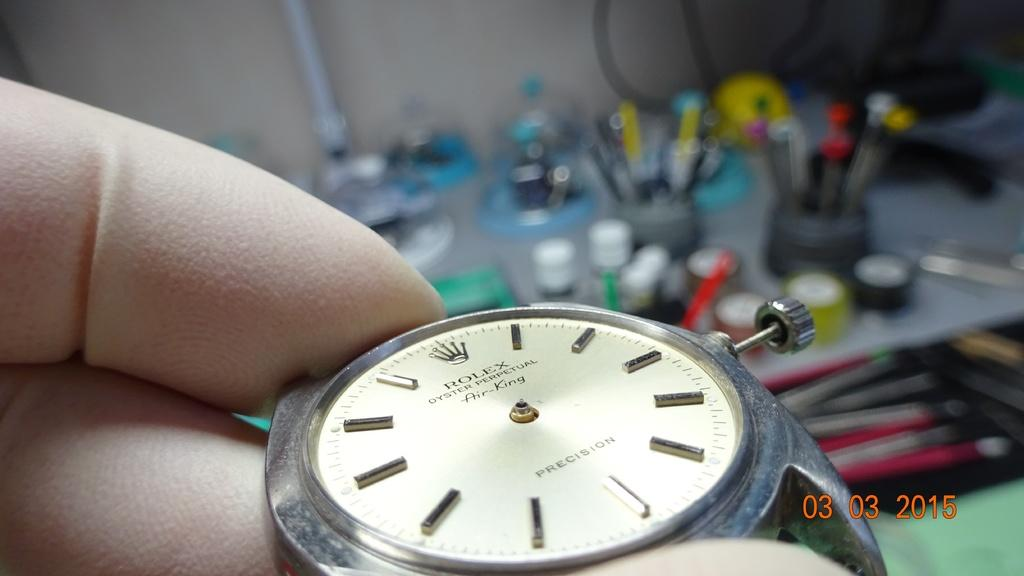<image>
Share a concise interpretation of the image provided. Person holding a watch which has a crown and the word ROLEX on it. 